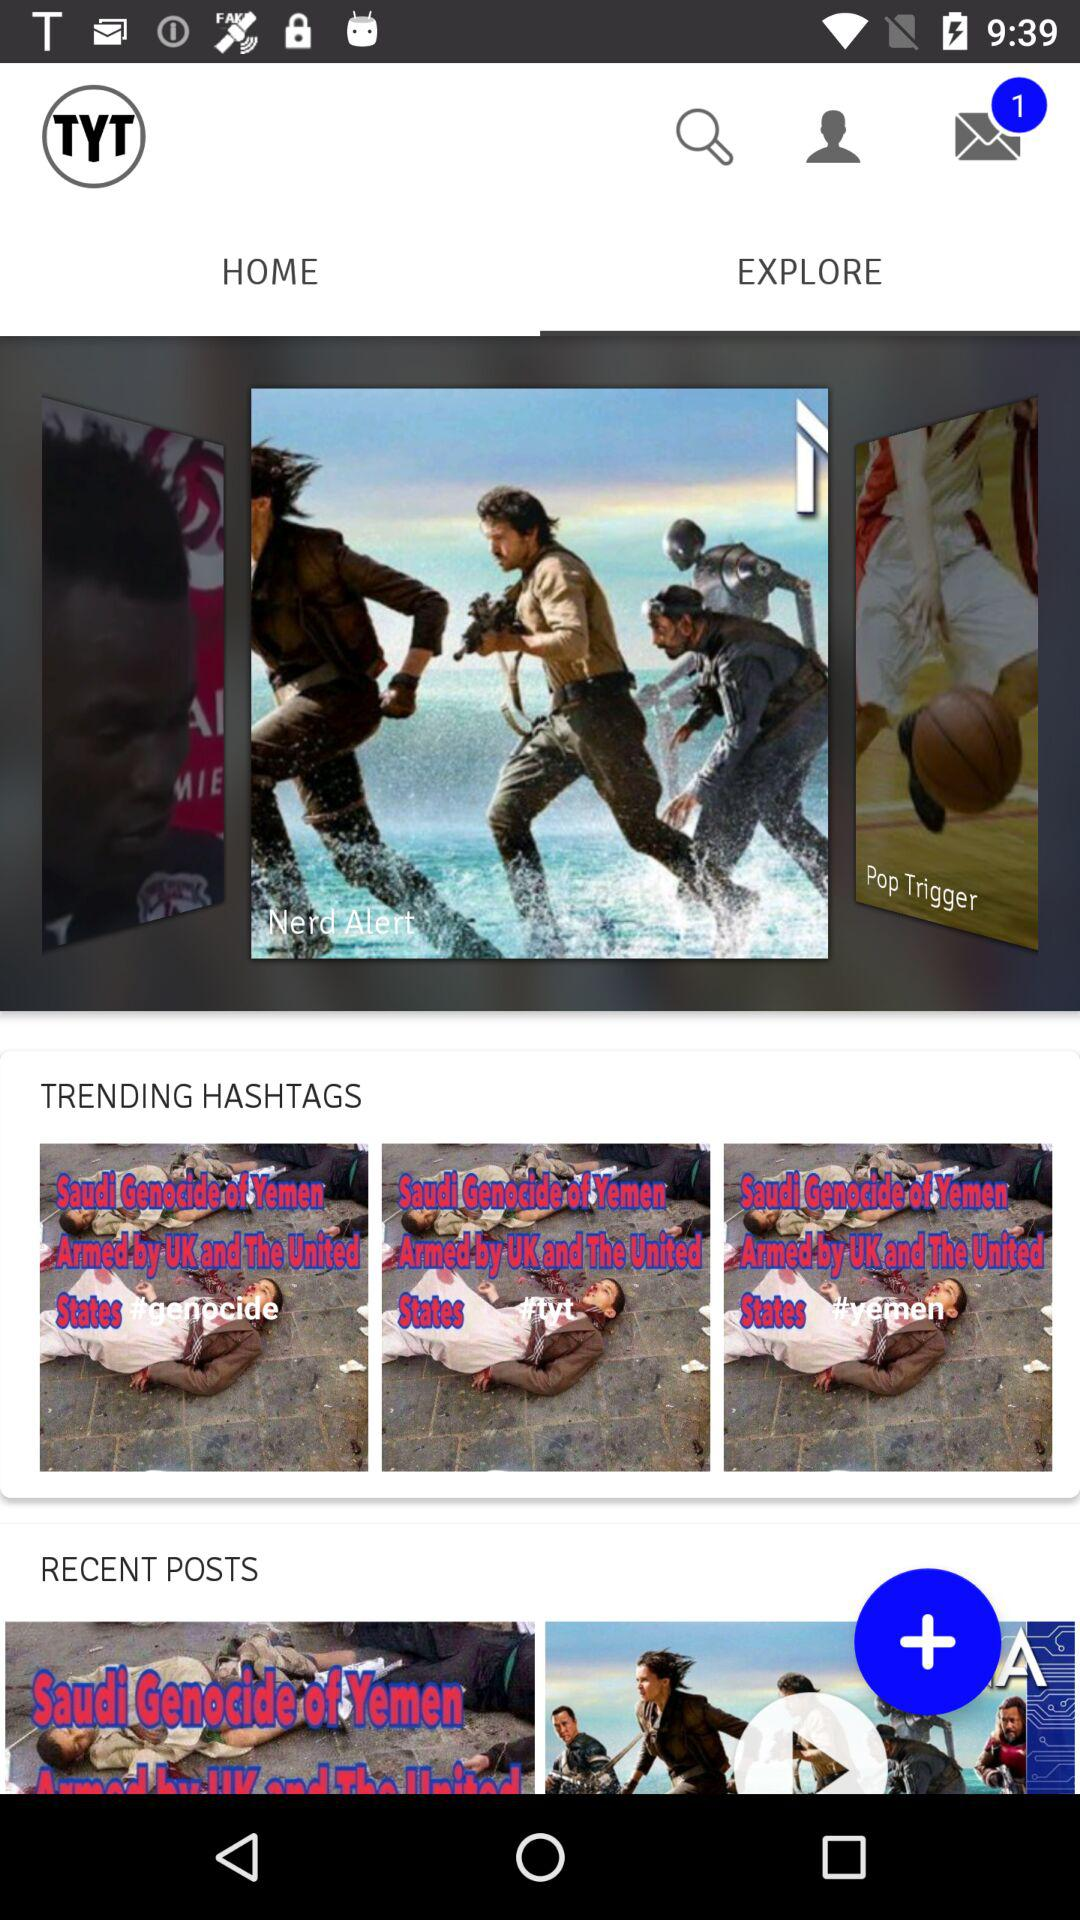Are there any unread messages? There is 1 unread message. 